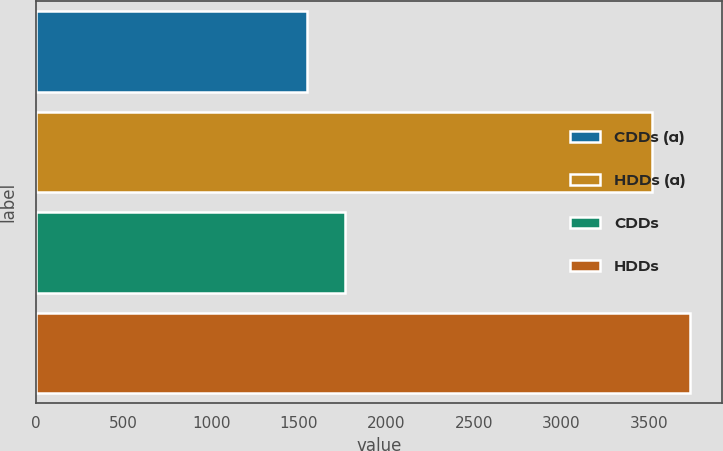<chart> <loc_0><loc_0><loc_500><loc_500><bar_chart><fcel>CDDs (a)<fcel>HDDs (a)<fcel>CDDs<fcel>HDDs<nl><fcel>1549<fcel>3521<fcel>1761.3<fcel>3733.3<nl></chart> 